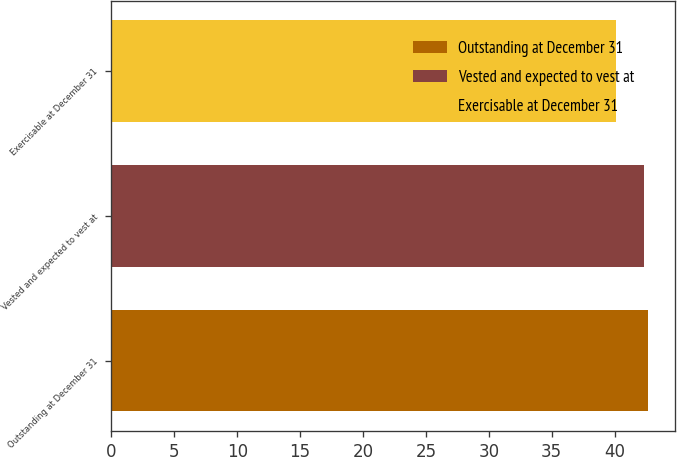Convert chart. <chart><loc_0><loc_0><loc_500><loc_500><bar_chart><fcel>Outstanding at December 31<fcel>Vested and expected to vest at<fcel>Exercisable at December 31<nl><fcel>42.64<fcel>42.31<fcel>40.09<nl></chart> 